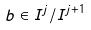Convert formula to latex. <formula><loc_0><loc_0><loc_500><loc_500>b \in I ^ { j } / I ^ { j + 1 }</formula> 